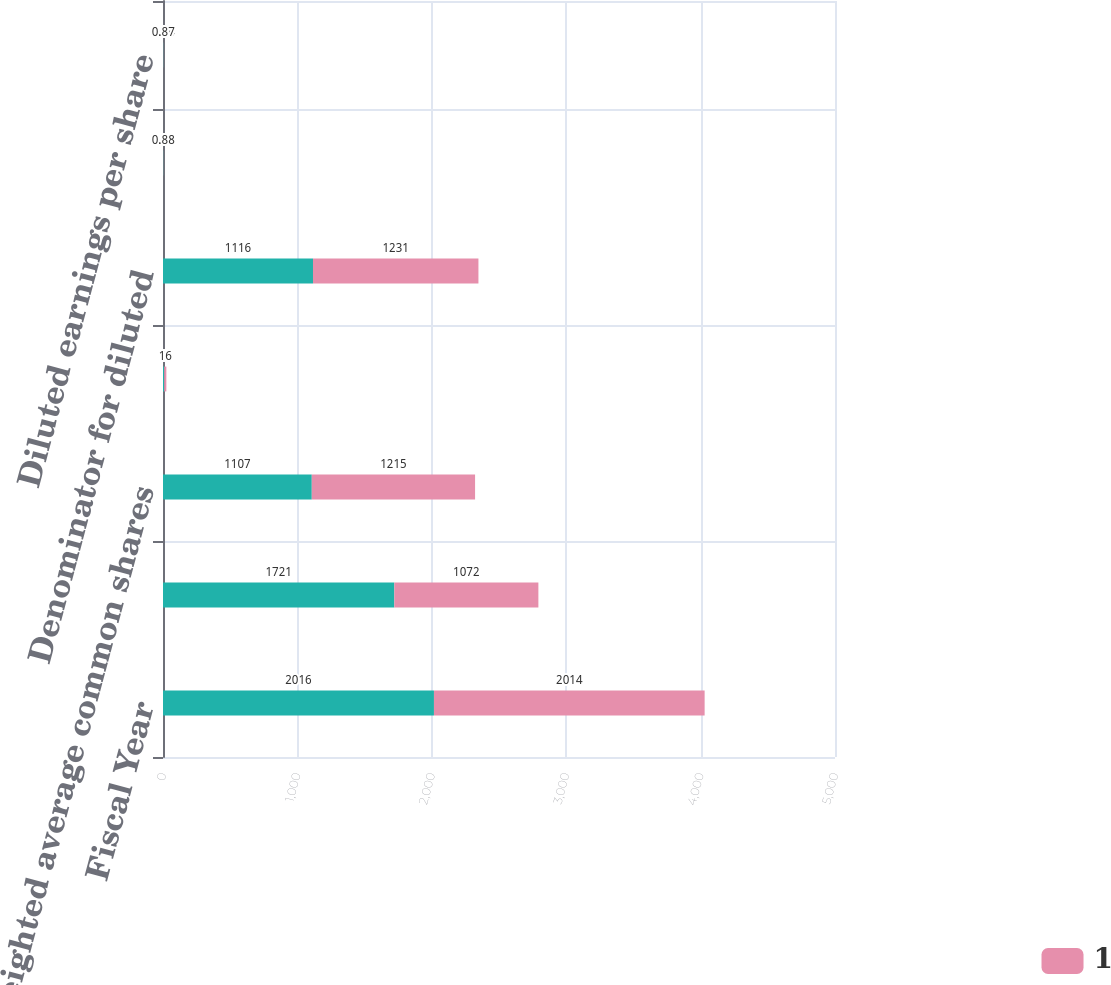Convert chart. <chart><loc_0><loc_0><loc_500><loc_500><stacked_bar_chart><ecel><fcel>Fiscal Year<fcel>Net income<fcel>Weighted average common shares<fcel>Effect of dilutive stock<fcel>Denominator for diluted<fcel>Basic earnings per share<fcel>Diluted earnings per share<nl><fcel>nan<fcel>2016<fcel>1721<fcel>1107<fcel>9<fcel>1116<fcel>1.56<fcel>1.54<nl><fcel>1<fcel>2014<fcel>1072<fcel>1215<fcel>16<fcel>1231<fcel>0.88<fcel>0.87<nl></chart> 